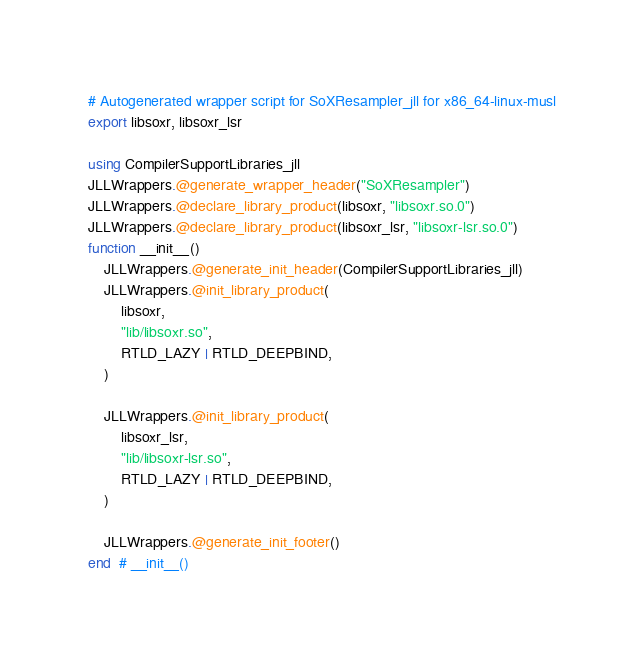<code> <loc_0><loc_0><loc_500><loc_500><_Julia_># Autogenerated wrapper script for SoXResampler_jll for x86_64-linux-musl
export libsoxr, libsoxr_lsr

using CompilerSupportLibraries_jll
JLLWrappers.@generate_wrapper_header("SoXResampler")
JLLWrappers.@declare_library_product(libsoxr, "libsoxr.so.0")
JLLWrappers.@declare_library_product(libsoxr_lsr, "libsoxr-lsr.so.0")
function __init__()
    JLLWrappers.@generate_init_header(CompilerSupportLibraries_jll)
    JLLWrappers.@init_library_product(
        libsoxr,
        "lib/libsoxr.so",
        RTLD_LAZY | RTLD_DEEPBIND,
    )

    JLLWrappers.@init_library_product(
        libsoxr_lsr,
        "lib/libsoxr-lsr.so",
        RTLD_LAZY | RTLD_DEEPBIND,
    )

    JLLWrappers.@generate_init_footer()
end  # __init__()
</code> 